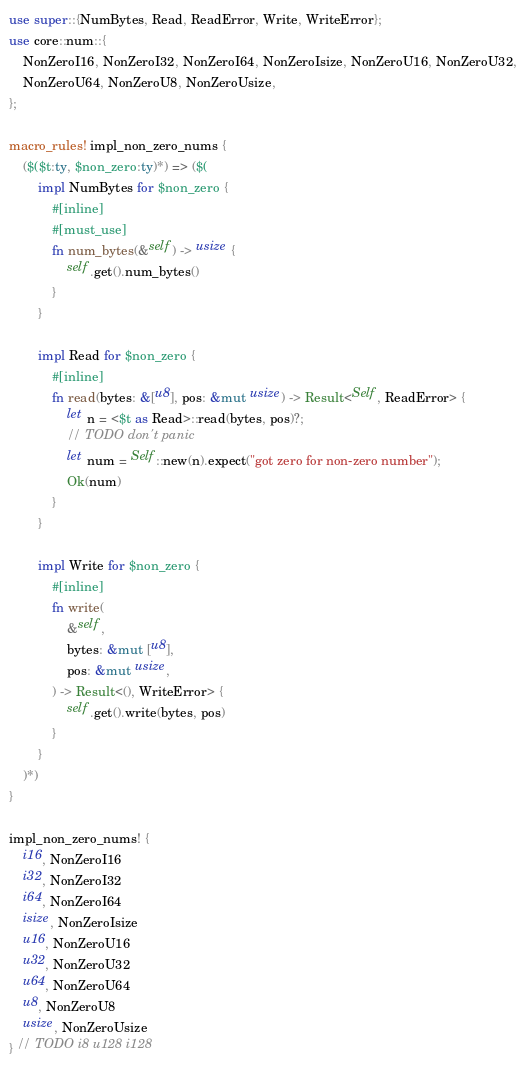<code> <loc_0><loc_0><loc_500><loc_500><_Rust_>use super::{NumBytes, Read, ReadError, Write, WriteError};
use core::num::{
    NonZeroI16, NonZeroI32, NonZeroI64, NonZeroIsize, NonZeroU16, NonZeroU32,
    NonZeroU64, NonZeroU8, NonZeroUsize,
};

macro_rules! impl_non_zero_nums {
    ($($t:ty, $non_zero:ty)*) => ($(
        impl NumBytes for $non_zero {
            #[inline]
            #[must_use]
            fn num_bytes(&self) -> usize {
                self.get().num_bytes()
            }
        }

        impl Read for $non_zero {
            #[inline]
            fn read(bytes: &[u8], pos: &mut usize) -> Result<Self, ReadError> {
                let n = <$t as Read>::read(bytes, pos)?;
                // TODO don't panic
                let num = Self::new(n).expect("got zero for non-zero number");
                Ok(num)
            }
        }

        impl Write for $non_zero {
            #[inline]
            fn write(
                &self,
                bytes: &mut [u8],
                pos: &mut usize,
            ) -> Result<(), WriteError> {
                self.get().write(bytes, pos)
            }
        }
    )*)
}

impl_non_zero_nums! {
    i16, NonZeroI16
    i32, NonZeroI32
    i64, NonZeroI64
    isize, NonZeroIsize
    u16, NonZeroU16
    u32, NonZeroU32
    u64, NonZeroU64
    u8, NonZeroU8
    usize, NonZeroUsize
} // TODO i8 u128 i128
</code> 